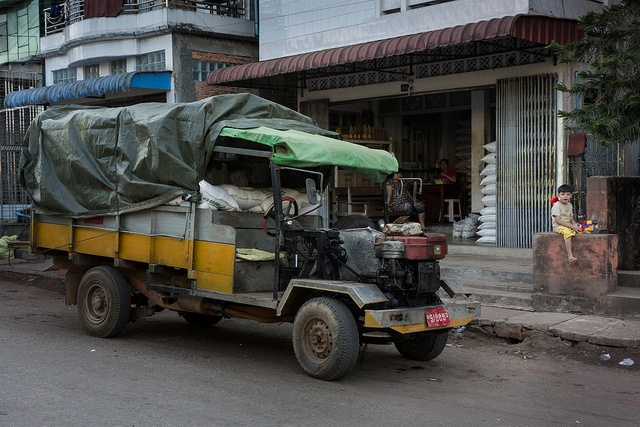Describe the objects in this image and their specific colors. I can see truck in teal, black, gray, darkgray, and olive tones, people in teal, darkgray, gray, and black tones, people in teal, black, gray, and maroon tones, chair in teal, black, and gray tones, and bottle in black, olive, maroon, and teal tones in this image. 